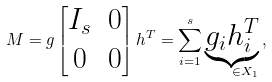<formula> <loc_0><loc_0><loc_500><loc_500>M = g \begin{bmatrix} I _ { s } & 0 \\ 0 & 0 \end{bmatrix} h ^ { T } = \sum _ { i = 1 } ^ { s } \underbrace { g _ { i } h _ { i } ^ { T } } _ { \quad \in X _ { 1 } } \, ,</formula> 